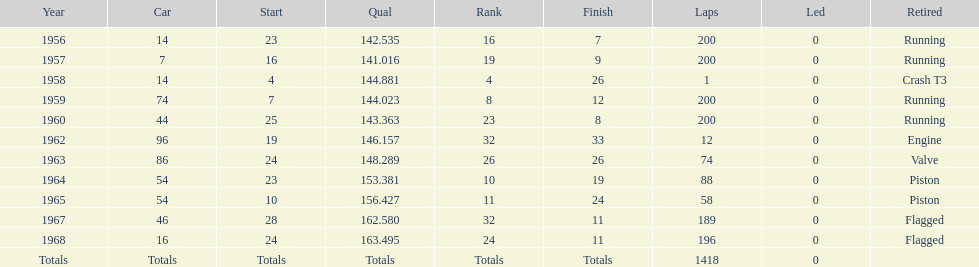When did he own a vehicle with an identical number to that of a car in 1964? 1965. 